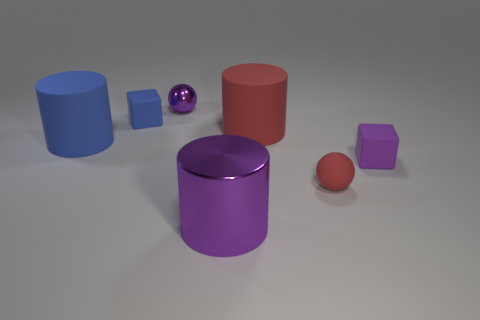Are there more big blue matte objects that are to the left of the big red matte object than rubber objects that are behind the purple ball?
Keep it short and to the point. Yes. What is the material of the big red cylinder?
Your response must be concise. Rubber. There is a purple thing behind the red matte thing behind the small block that is in front of the tiny blue thing; what shape is it?
Give a very brief answer. Sphere. What number of other objects are there of the same material as the tiny red sphere?
Offer a terse response. 4. Is the tiny purple object on the right side of the red ball made of the same material as the large cylinder that is to the left of the small blue rubber thing?
Provide a succinct answer. Yes. How many objects are both on the left side of the small red thing and to the right of the big blue rubber object?
Offer a very short reply. 4. Is there a tiny brown metal thing of the same shape as the large red thing?
Provide a succinct answer. No. There is a blue thing that is the same size as the purple metallic cylinder; what shape is it?
Your answer should be compact. Cylinder. Are there an equal number of tiny red rubber objects that are behind the blue cylinder and tiny rubber cubes right of the tiny blue rubber object?
Keep it short and to the point. No. There is a purple shiny object that is to the left of the metallic object that is in front of the big red cylinder; what size is it?
Your answer should be compact. Small. 